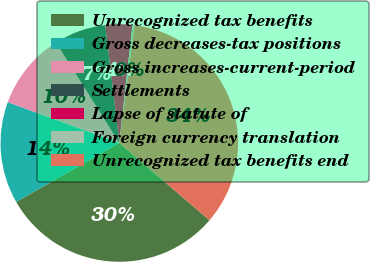<chart> <loc_0><loc_0><loc_500><loc_500><pie_chart><fcel>Unrecognized tax benefits<fcel>Gross decreases-tax positions<fcel>Gross increases-current-period<fcel>Settlements<fcel>Lapse of statute of<fcel>Foreign currency translation<fcel>Unrecognized tax benefits end<nl><fcel>30.47%<fcel>13.85%<fcel>10.46%<fcel>7.06%<fcel>3.66%<fcel>0.27%<fcel>34.23%<nl></chart> 